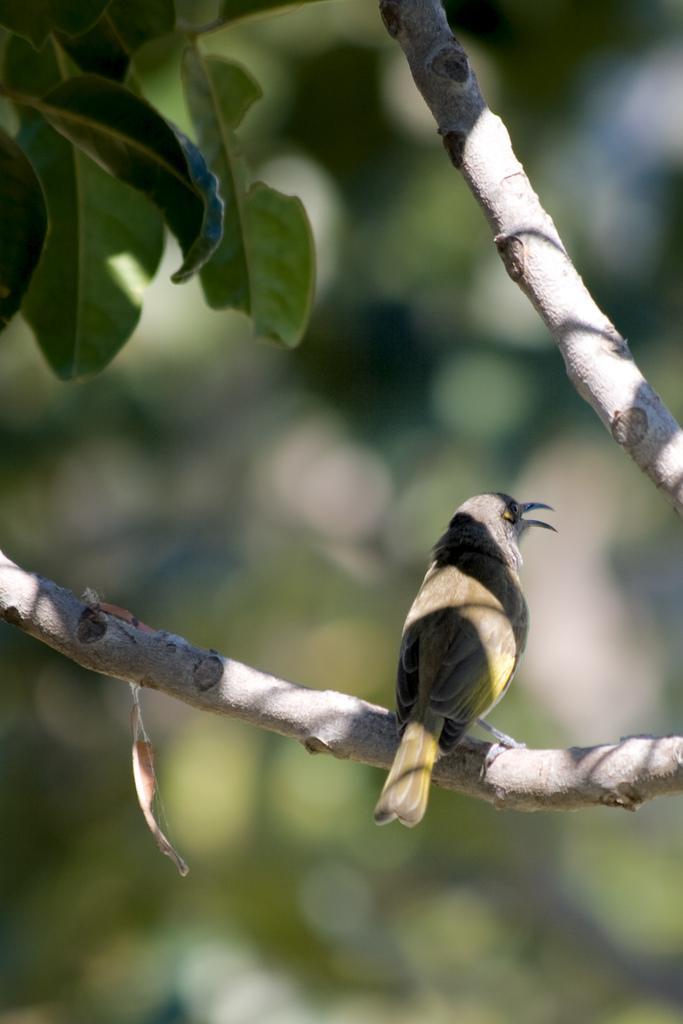Could you give a brief overview of what you see in this image? In this image we can see a bird which is of color brown is on the branch of a tree and at the background of the image there are some leaves. 